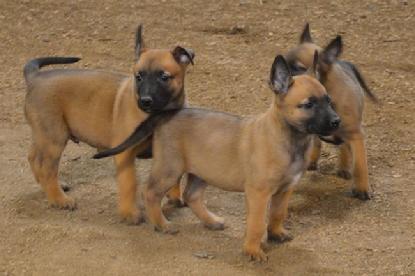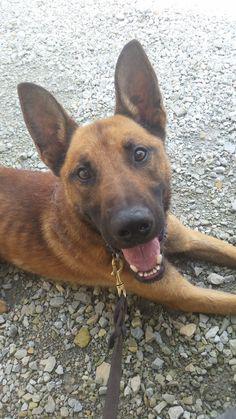The first image is the image on the left, the second image is the image on the right. Considering the images on both sides, is "One dog is lying down." valid? Answer yes or no. Yes. The first image is the image on the left, the second image is the image on the right. Assess this claim about the two images: "The right image contains one german shepherd on pavement, looking upward with his head cocked rightward.". Correct or not? Answer yes or no. Yes. 